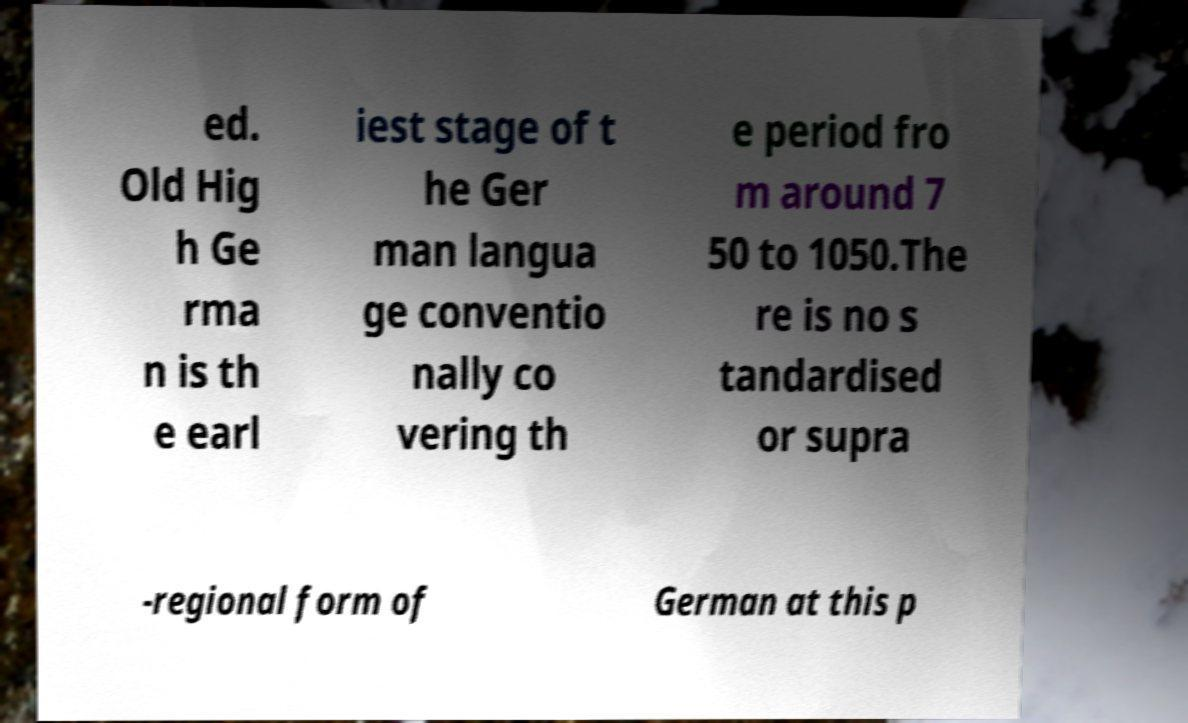Please identify and transcribe the text found in this image. ed. Old Hig h Ge rma n is th e earl iest stage of t he Ger man langua ge conventio nally co vering th e period fro m around 7 50 to 1050.The re is no s tandardised or supra -regional form of German at this p 